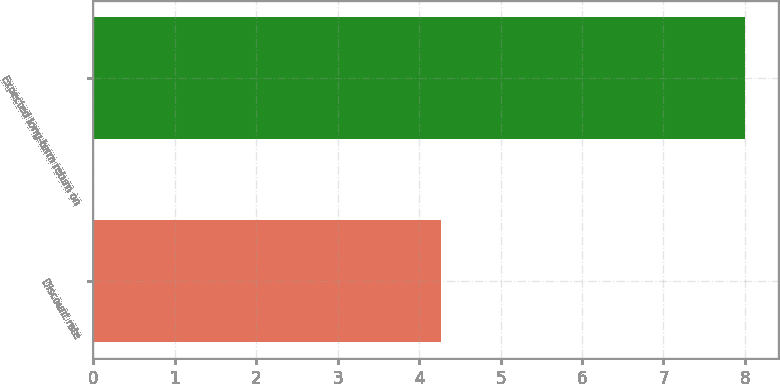Convert chart to OTSL. <chart><loc_0><loc_0><loc_500><loc_500><bar_chart><fcel>Discount rate<fcel>Expected long-term return on<nl><fcel>4.27<fcel>8<nl></chart> 